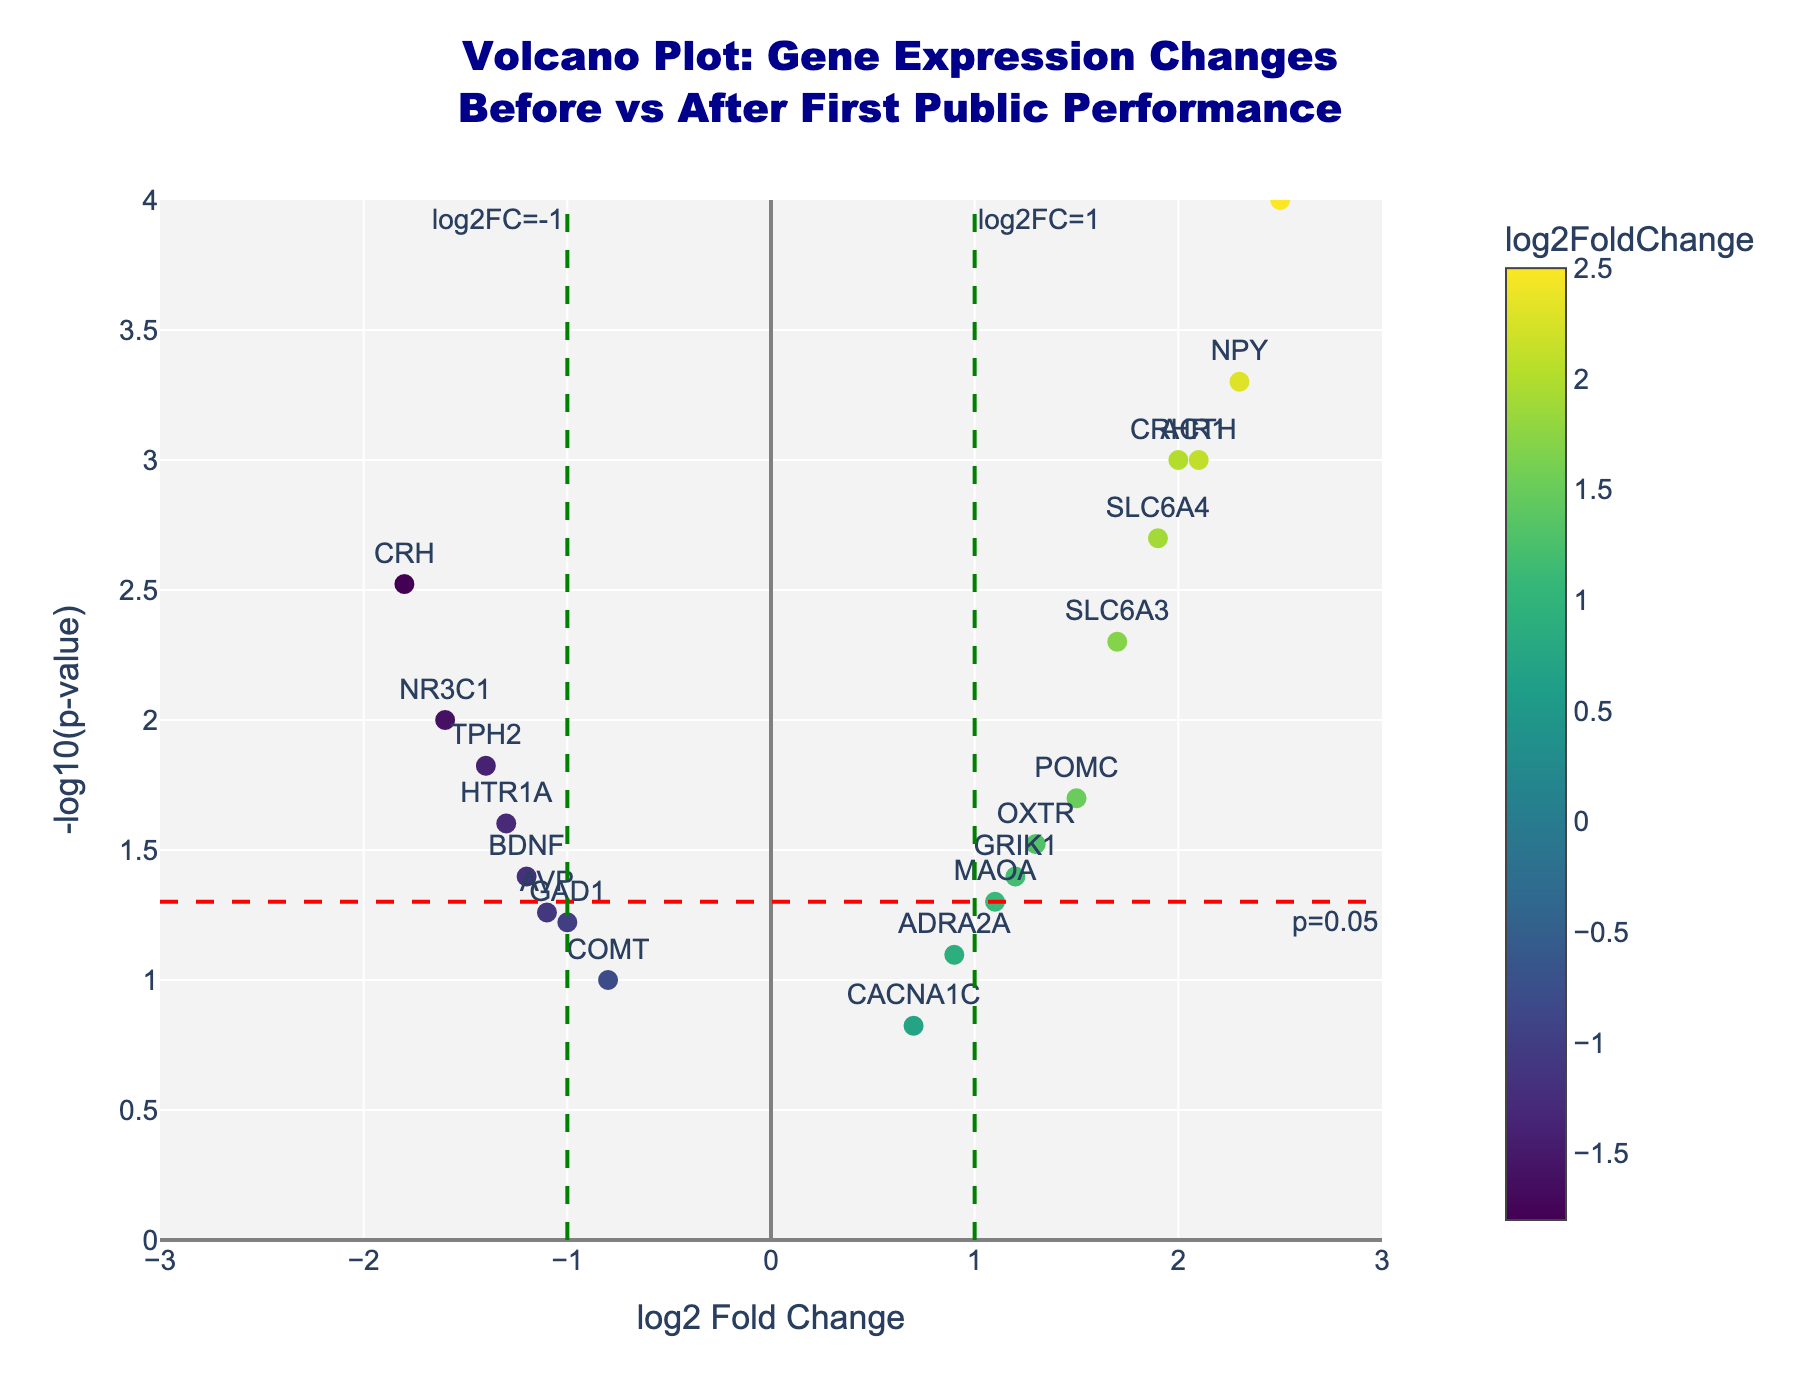What is the title of the volcano plot? The title is displayed at the top of the figure in a larger, bold font. It summarizes what the plot is about.
Answer: Volcano Plot: Gene Expression Changes Before vs After First Public Performance How is the significance threshold visually indicated on the plot? There is a dashed horizontal line marked in red with an annotation text "p=0.05" positioned at the bottom right. This line represents the significance threshold.
Answer: Red dashed line annotated with "p=0.05" Which gene has the highest log2 Fold Change? By looking at the x-axis values, the gene with the highest log2 Fold Change is on the far right of the plot. The name placed at this position indicates the gene with the highest log2FC.
Answer: FKBP5 Which genes are considered significantly upregulated after the first performance? Significant genes have a -log10(p-value) above the red dashed line (p < 0.05) and a log2FC greater than 0. Identify the genes positioned in the upper right part of the plot beyond the red dashed line.
Answer: ACTH, NPY, SLC6A4, FKBP5, CRHR1, SLC6A3 How many genes have a log2 Fold Change greater than 1? Count the number of points that are to the right of the green dashed line annotated with "log2FC=1".
Answer: 4 genes Which gene has both a relatively high log2 Fold Change and a low significance level? Look for a point that is far to the right (large positive log2FC) and just below the red dashed line indicating the significance threshold (p > 0.05).
Answer: MAOA Are there any genes that have a negative log2 Fold Change and are also not significantly differentially expressed? Genes with a negative log2FC are on the left side of the plot, and those not significantly different have p-values higher than 0.05, indicated by being below the red dashed line.
Answer: COMT, GAD1, AVP Which gene shows the highest p-value among the significantly differentially expressed ones? Among the points above the red dashed line, find the one that is closest to the red line, indicating the highest p-value.
Answer: POMC How many genes have a p-value less than 0.01? Count the number of points that are above the y-value -log10(0.01), which is around 2 on the y-axis.
Answer: 7 genes Is there a gene that has the same log2 Fold Change but different significance levels? Compare the x-values (log2 Fold Changes) and see if any two points line up vertically but are positioned differently along the y-axis.
Answer: Yes, there are genes like CRHR1 and ACTH 